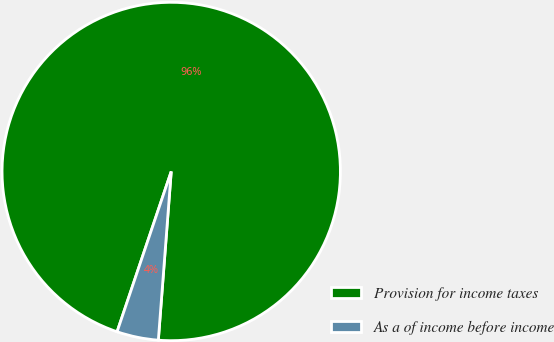Convert chart. <chart><loc_0><loc_0><loc_500><loc_500><pie_chart><fcel>Provision for income taxes<fcel>As a of income before income<nl><fcel>96.03%<fcel>3.97%<nl></chart> 